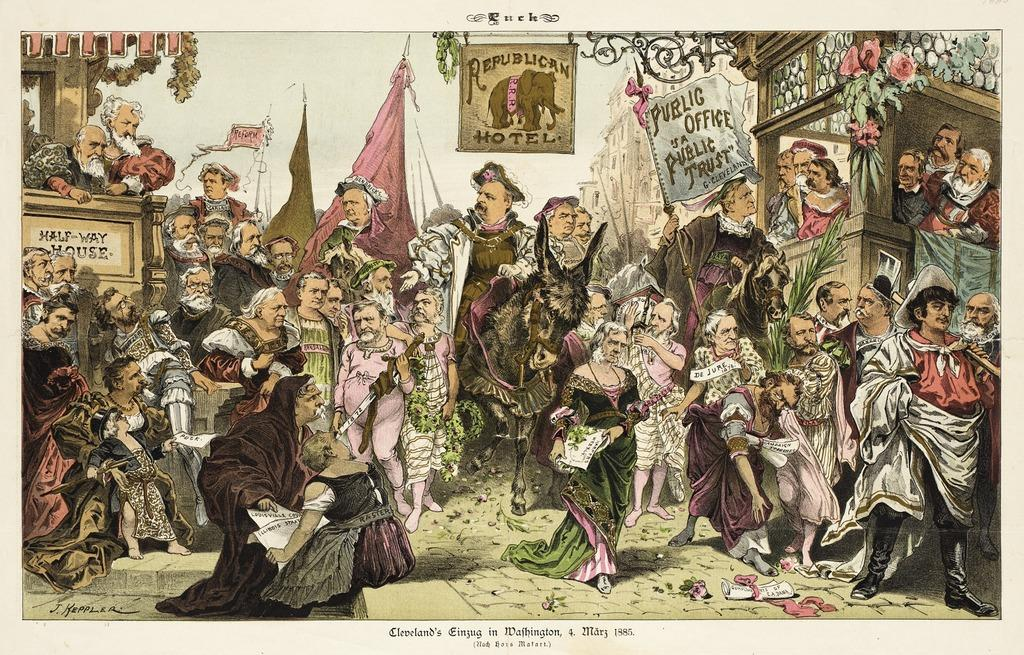<image>
Describe the image concisely. A gathering beneath a flag that says public office is public trust 